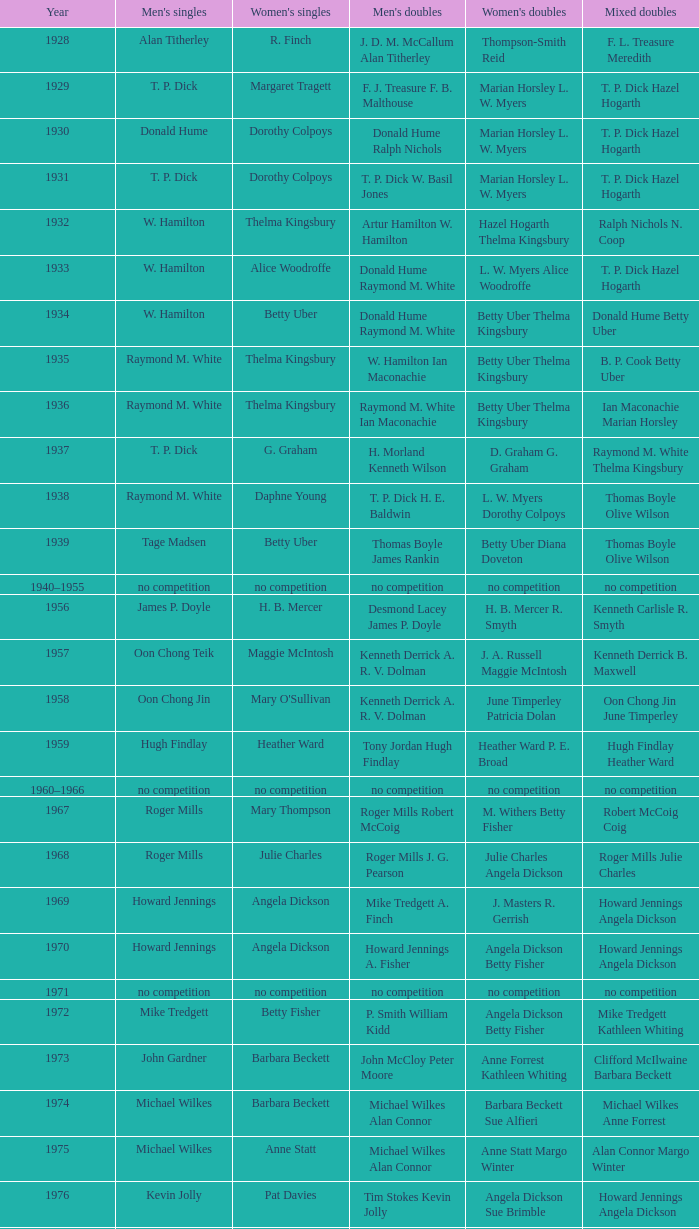Who claimed the men's singles title when ian maconachie marian horsley triumphed in the mixed doubles? Raymond M. White. 